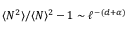<formula> <loc_0><loc_0><loc_500><loc_500>\langle N ^ { 2 } \rangle / \langle N \rangle ^ { 2 } - 1 \sim \ell ^ { - ( d + \alpha ) }</formula> 